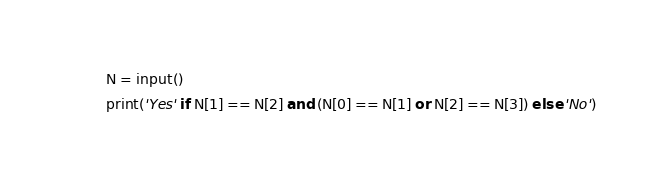Convert code to text. <code><loc_0><loc_0><loc_500><loc_500><_Python_>N = input()
print('Yes' if N[1] == N[2] and (N[0] == N[1] or N[2] == N[3]) else 'No')</code> 